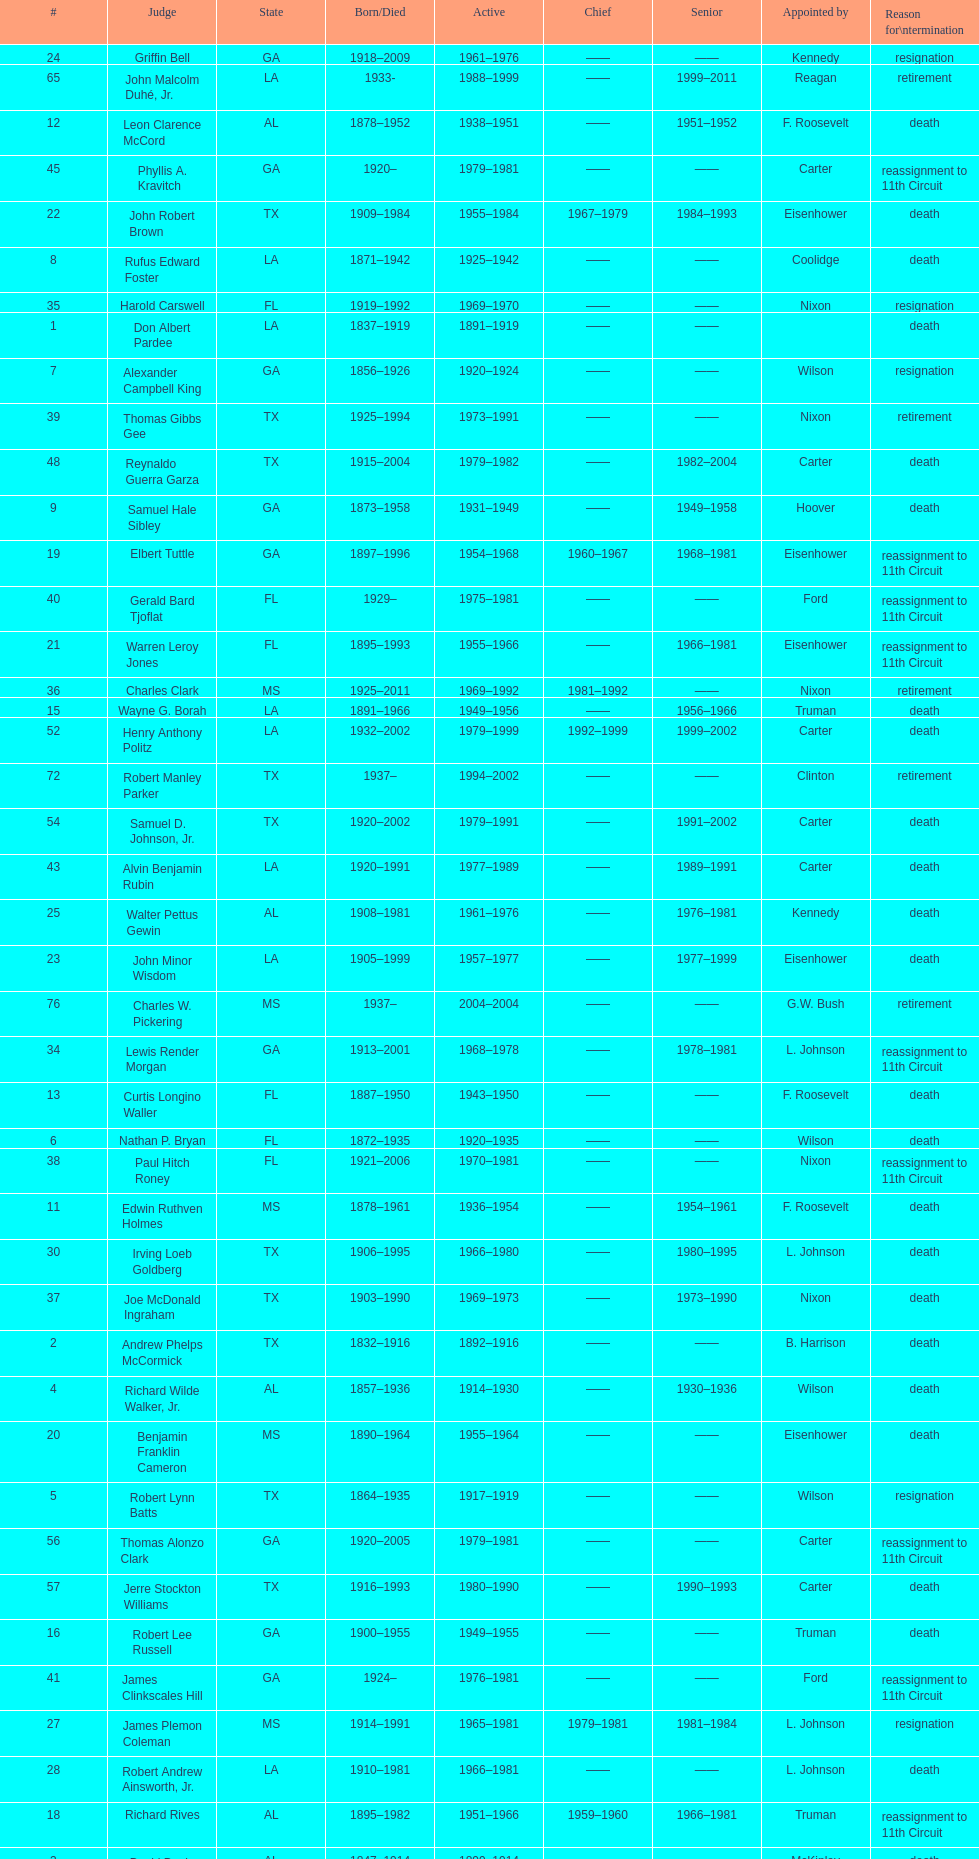How many judges served as chief total? 8. 